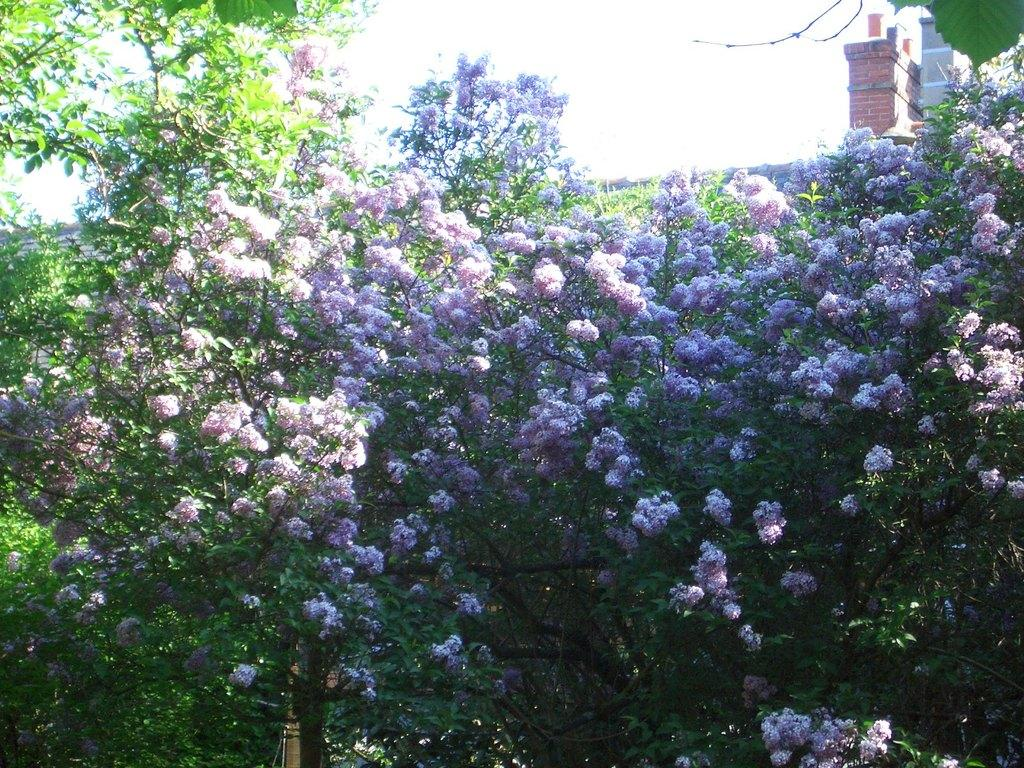What type of plants can be seen in the image? There are green color plants in the image. What additional features can be observed on the plants? There are flowers on the plants. What is visible at the top of the image? The sky is visible at the top of the image. What type of print can be seen on the vase in the image? There is no vase present in the image, so it is not possible to answer that question. 